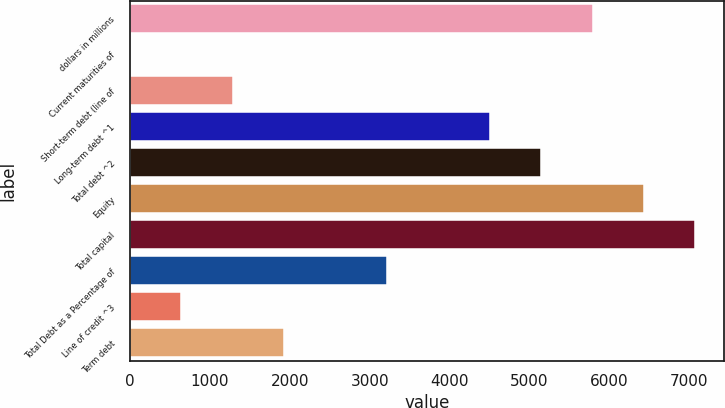Convert chart. <chart><loc_0><loc_0><loc_500><loc_500><bar_chart><fcel>dollars in millions<fcel>Current maturities of<fcel>Short-term debt (line of<fcel>Long-term debt ^1<fcel>Total debt ^2<fcel>Equity<fcel>Total capital<fcel>Total Debt as a Percentage of<fcel>Line of credit ^3<fcel>Term debt<nl><fcel>5791.15<fcel>0.1<fcel>1287<fcel>4504.25<fcel>5147.7<fcel>6434.6<fcel>7078.05<fcel>3217.35<fcel>643.55<fcel>1930.45<nl></chart> 